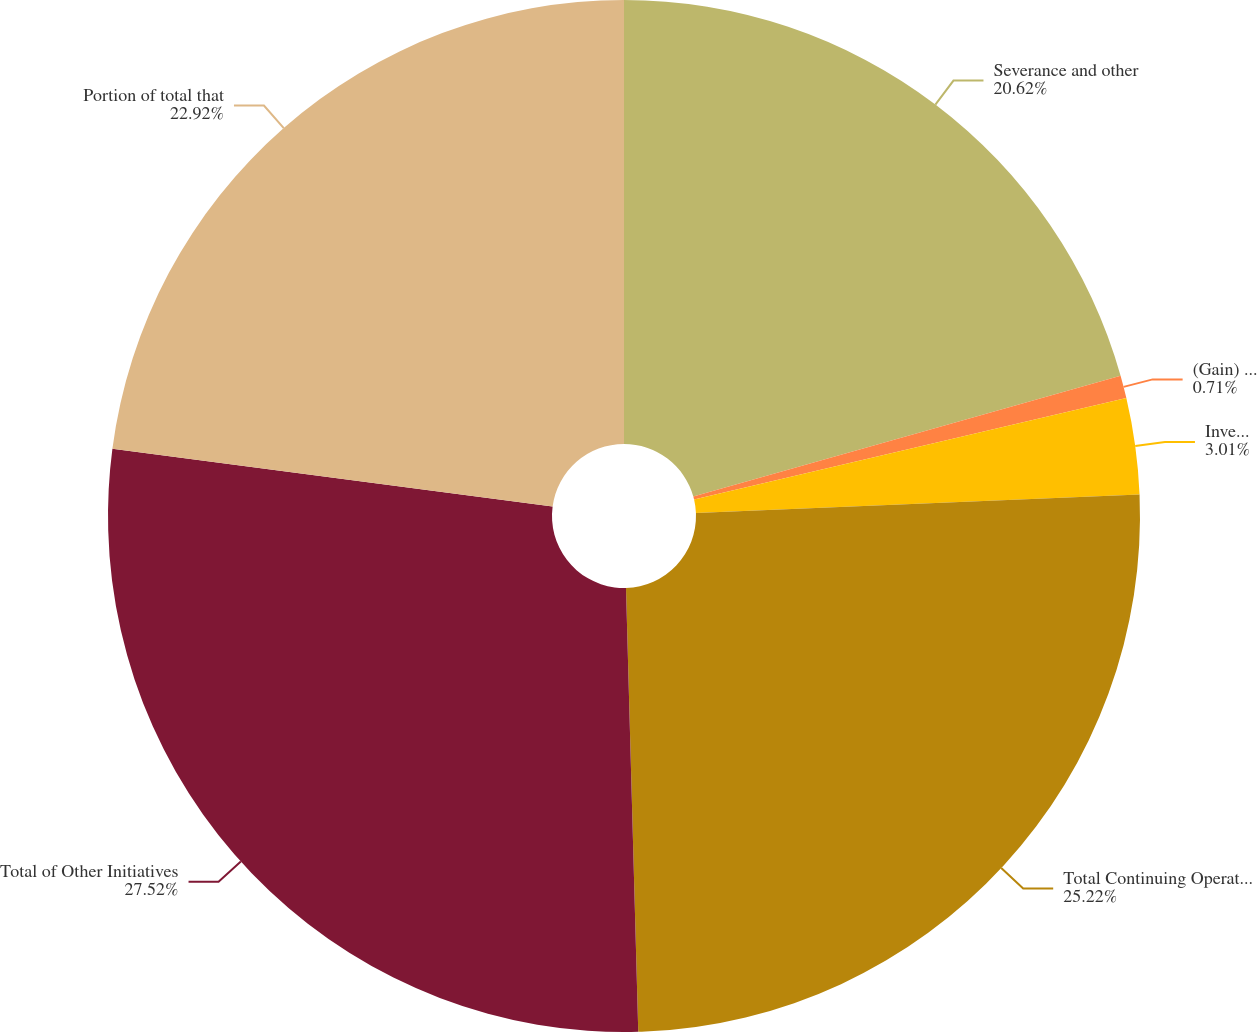<chart> <loc_0><loc_0><loc_500><loc_500><pie_chart><fcel>Severance and other<fcel>(Gain) loss from sale of<fcel>Inventory obsolescence and<fcel>Total Continuing Operations<fcel>Total of Other Initiatives<fcel>Portion of total that<nl><fcel>20.62%<fcel>0.71%<fcel>3.01%<fcel>25.22%<fcel>27.52%<fcel>22.92%<nl></chart> 